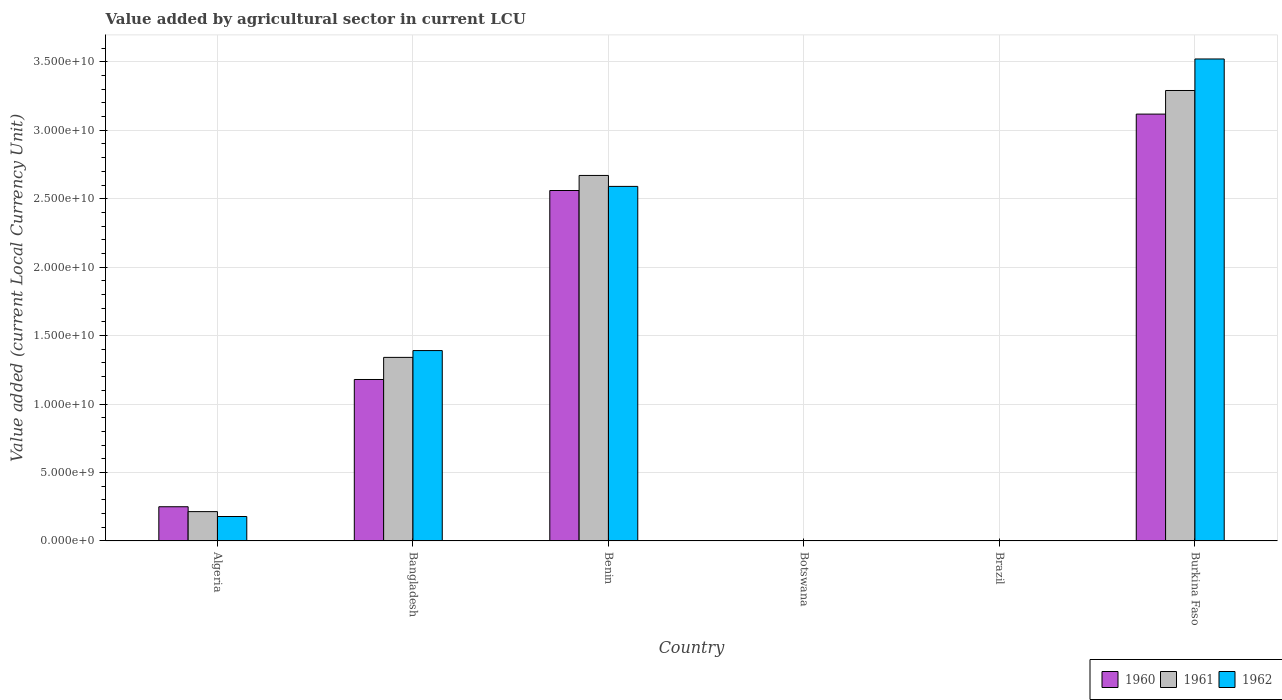Are the number of bars per tick equal to the number of legend labels?
Provide a short and direct response. Yes. How many bars are there on the 5th tick from the right?
Your answer should be very brief. 3. What is the label of the 6th group of bars from the left?
Make the answer very short. Burkina Faso. In how many cases, is the number of bars for a given country not equal to the number of legend labels?
Your response must be concise. 0. What is the value added by agricultural sector in 1960 in Brazil?
Your answer should be compact. 0. Across all countries, what is the maximum value added by agricultural sector in 1962?
Offer a terse response. 3.52e+1. Across all countries, what is the minimum value added by agricultural sector in 1960?
Ensure brevity in your answer.  0. In which country was the value added by agricultural sector in 1962 maximum?
Provide a succinct answer. Burkina Faso. What is the total value added by agricultural sector in 1960 in the graph?
Your answer should be very brief. 7.11e+1. What is the difference between the value added by agricultural sector in 1961 in Brazil and that in Burkina Faso?
Your answer should be very brief. -3.29e+1. What is the difference between the value added by agricultural sector in 1960 in Bangladesh and the value added by agricultural sector in 1961 in Burkina Faso?
Keep it short and to the point. -2.11e+1. What is the average value added by agricultural sector in 1962 per country?
Provide a succinct answer. 1.28e+1. What is the difference between the value added by agricultural sector of/in 1962 and value added by agricultural sector of/in 1961 in Burkina Faso?
Give a very brief answer. 2.30e+09. In how many countries, is the value added by agricultural sector in 1961 greater than 14000000000 LCU?
Provide a short and direct response. 2. What is the ratio of the value added by agricultural sector in 1962 in Bangladesh to that in Benin?
Give a very brief answer. 0.54. Is the difference between the value added by agricultural sector in 1962 in Brazil and Burkina Faso greater than the difference between the value added by agricultural sector in 1961 in Brazil and Burkina Faso?
Provide a short and direct response. No. What is the difference between the highest and the second highest value added by agricultural sector in 1962?
Give a very brief answer. 9.31e+09. What is the difference between the highest and the lowest value added by agricultural sector in 1960?
Ensure brevity in your answer.  3.12e+1. Are all the bars in the graph horizontal?
Ensure brevity in your answer.  No. What is the difference between two consecutive major ticks on the Y-axis?
Provide a succinct answer. 5.00e+09. Are the values on the major ticks of Y-axis written in scientific E-notation?
Your answer should be compact. Yes. Does the graph contain grids?
Ensure brevity in your answer.  Yes. Where does the legend appear in the graph?
Provide a short and direct response. Bottom right. How many legend labels are there?
Give a very brief answer. 3. How are the legend labels stacked?
Provide a short and direct response. Horizontal. What is the title of the graph?
Your answer should be very brief. Value added by agricultural sector in current LCU. What is the label or title of the X-axis?
Ensure brevity in your answer.  Country. What is the label or title of the Y-axis?
Provide a short and direct response. Value added (current Local Currency Unit). What is the Value added (current Local Currency Unit) of 1960 in Algeria?
Your answer should be compact. 2.50e+09. What is the Value added (current Local Currency Unit) in 1961 in Algeria?
Your answer should be compact. 2.14e+09. What is the Value added (current Local Currency Unit) of 1962 in Algeria?
Provide a succinct answer. 1.78e+09. What is the Value added (current Local Currency Unit) of 1960 in Bangladesh?
Ensure brevity in your answer.  1.18e+1. What is the Value added (current Local Currency Unit) of 1961 in Bangladesh?
Your response must be concise. 1.34e+1. What is the Value added (current Local Currency Unit) of 1962 in Bangladesh?
Provide a short and direct response. 1.39e+1. What is the Value added (current Local Currency Unit) of 1960 in Benin?
Your response must be concise. 2.56e+1. What is the Value added (current Local Currency Unit) in 1961 in Benin?
Your answer should be compact. 2.67e+1. What is the Value added (current Local Currency Unit) in 1962 in Benin?
Provide a succinct answer. 2.59e+1. What is the Value added (current Local Currency Unit) in 1960 in Botswana?
Offer a terse response. 9.38e+06. What is the Value added (current Local Currency Unit) in 1961 in Botswana?
Provide a succinct answer. 9.86e+06. What is the Value added (current Local Currency Unit) in 1962 in Botswana?
Your answer should be compact. 1.03e+07. What is the Value added (current Local Currency Unit) in 1960 in Brazil?
Keep it short and to the point. 0. What is the Value added (current Local Currency Unit) in 1961 in Brazil?
Make the answer very short. 0. What is the Value added (current Local Currency Unit) of 1962 in Brazil?
Ensure brevity in your answer.  0. What is the Value added (current Local Currency Unit) of 1960 in Burkina Faso?
Keep it short and to the point. 3.12e+1. What is the Value added (current Local Currency Unit) of 1961 in Burkina Faso?
Your response must be concise. 3.29e+1. What is the Value added (current Local Currency Unit) of 1962 in Burkina Faso?
Provide a succinct answer. 3.52e+1. Across all countries, what is the maximum Value added (current Local Currency Unit) in 1960?
Ensure brevity in your answer.  3.12e+1. Across all countries, what is the maximum Value added (current Local Currency Unit) of 1961?
Offer a terse response. 3.29e+1. Across all countries, what is the maximum Value added (current Local Currency Unit) in 1962?
Ensure brevity in your answer.  3.52e+1. Across all countries, what is the minimum Value added (current Local Currency Unit) of 1960?
Your answer should be compact. 0. Across all countries, what is the minimum Value added (current Local Currency Unit) of 1961?
Make the answer very short. 0. Across all countries, what is the minimum Value added (current Local Currency Unit) in 1962?
Make the answer very short. 0. What is the total Value added (current Local Currency Unit) in 1960 in the graph?
Your answer should be very brief. 7.11e+1. What is the total Value added (current Local Currency Unit) of 1961 in the graph?
Your answer should be very brief. 7.52e+1. What is the total Value added (current Local Currency Unit) of 1962 in the graph?
Your answer should be compact. 7.68e+1. What is the difference between the Value added (current Local Currency Unit) in 1960 in Algeria and that in Bangladesh?
Keep it short and to the point. -9.29e+09. What is the difference between the Value added (current Local Currency Unit) in 1961 in Algeria and that in Bangladesh?
Ensure brevity in your answer.  -1.13e+1. What is the difference between the Value added (current Local Currency Unit) of 1962 in Algeria and that in Bangladesh?
Provide a short and direct response. -1.21e+1. What is the difference between the Value added (current Local Currency Unit) of 1960 in Algeria and that in Benin?
Give a very brief answer. -2.31e+1. What is the difference between the Value added (current Local Currency Unit) of 1961 in Algeria and that in Benin?
Make the answer very short. -2.46e+1. What is the difference between the Value added (current Local Currency Unit) of 1962 in Algeria and that in Benin?
Make the answer very short. -2.41e+1. What is the difference between the Value added (current Local Currency Unit) of 1960 in Algeria and that in Botswana?
Give a very brief answer. 2.49e+09. What is the difference between the Value added (current Local Currency Unit) of 1961 in Algeria and that in Botswana?
Your response must be concise. 2.13e+09. What is the difference between the Value added (current Local Currency Unit) of 1962 in Algeria and that in Botswana?
Offer a very short reply. 1.77e+09. What is the difference between the Value added (current Local Currency Unit) in 1960 in Algeria and that in Brazil?
Offer a terse response. 2.50e+09. What is the difference between the Value added (current Local Currency Unit) of 1961 in Algeria and that in Brazil?
Your response must be concise. 2.14e+09. What is the difference between the Value added (current Local Currency Unit) of 1962 in Algeria and that in Brazil?
Ensure brevity in your answer.  1.78e+09. What is the difference between the Value added (current Local Currency Unit) of 1960 in Algeria and that in Burkina Faso?
Provide a short and direct response. -2.87e+1. What is the difference between the Value added (current Local Currency Unit) in 1961 in Algeria and that in Burkina Faso?
Ensure brevity in your answer.  -3.08e+1. What is the difference between the Value added (current Local Currency Unit) in 1962 in Algeria and that in Burkina Faso?
Provide a succinct answer. -3.34e+1. What is the difference between the Value added (current Local Currency Unit) in 1960 in Bangladesh and that in Benin?
Your answer should be compact. -1.38e+1. What is the difference between the Value added (current Local Currency Unit) of 1961 in Bangladesh and that in Benin?
Offer a terse response. -1.33e+1. What is the difference between the Value added (current Local Currency Unit) in 1962 in Bangladesh and that in Benin?
Make the answer very short. -1.20e+1. What is the difference between the Value added (current Local Currency Unit) of 1960 in Bangladesh and that in Botswana?
Offer a very short reply. 1.18e+1. What is the difference between the Value added (current Local Currency Unit) of 1961 in Bangladesh and that in Botswana?
Offer a terse response. 1.34e+1. What is the difference between the Value added (current Local Currency Unit) of 1962 in Bangladesh and that in Botswana?
Give a very brief answer. 1.39e+1. What is the difference between the Value added (current Local Currency Unit) of 1960 in Bangladesh and that in Brazil?
Ensure brevity in your answer.  1.18e+1. What is the difference between the Value added (current Local Currency Unit) in 1961 in Bangladesh and that in Brazil?
Provide a short and direct response. 1.34e+1. What is the difference between the Value added (current Local Currency Unit) of 1962 in Bangladesh and that in Brazil?
Provide a short and direct response. 1.39e+1. What is the difference between the Value added (current Local Currency Unit) of 1960 in Bangladesh and that in Burkina Faso?
Offer a terse response. -1.94e+1. What is the difference between the Value added (current Local Currency Unit) of 1961 in Bangladesh and that in Burkina Faso?
Give a very brief answer. -1.95e+1. What is the difference between the Value added (current Local Currency Unit) in 1962 in Bangladesh and that in Burkina Faso?
Provide a succinct answer. -2.13e+1. What is the difference between the Value added (current Local Currency Unit) of 1960 in Benin and that in Botswana?
Your answer should be very brief. 2.56e+1. What is the difference between the Value added (current Local Currency Unit) of 1961 in Benin and that in Botswana?
Your answer should be compact. 2.67e+1. What is the difference between the Value added (current Local Currency Unit) in 1962 in Benin and that in Botswana?
Give a very brief answer. 2.59e+1. What is the difference between the Value added (current Local Currency Unit) in 1960 in Benin and that in Brazil?
Your answer should be very brief. 2.56e+1. What is the difference between the Value added (current Local Currency Unit) in 1961 in Benin and that in Brazil?
Your response must be concise. 2.67e+1. What is the difference between the Value added (current Local Currency Unit) in 1962 in Benin and that in Brazil?
Keep it short and to the point. 2.59e+1. What is the difference between the Value added (current Local Currency Unit) of 1960 in Benin and that in Burkina Faso?
Your answer should be compact. -5.58e+09. What is the difference between the Value added (current Local Currency Unit) in 1961 in Benin and that in Burkina Faso?
Keep it short and to the point. -6.21e+09. What is the difference between the Value added (current Local Currency Unit) of 1962 in Benin and that in Burkina Faso?
Offer a terse response. -9.31e+09. What is the difference between the Value added (current Local Currency Unit) in 1960 in Botswana and that in Brazil?
Offer a very short reply. 9.38e+06. What is the difference between the Value added (current Local Currency Unit) in 1961 in Botswana and that in Brazil?
Provide a short and direct response. 9.86e+06. What is the difference between the Value added (current Local Currency Unit) of 1962 in Botswana and that in Brazil?
Ensure brevity in your answer.  1.03e+07. What is the difference between the Value added (current Local Currency Unit) in 1960 in Botswana and that in Burkina Faso?
Provide a succinct answer. -3.12e+1. What is the difference between the Value added (current Local Currency Unit) of 1961 in Botswana and that in Burkina Faso?
Offer a terse response. -3.29e+1. What is the difference between the Value added (current Local Currency Unit) of 1962 in Botswana and that in Burkina Faso?
Your response must be concise. -3.52e+1. What is the difference between the Value added (current Local Currency Unit) of 1960 in Brazil and that in Burkina Faso?
Give a very brief answer. -3.12e+1. What is the difference between the Value added (current Local Currency Unit) in 1961 in Brazil and that in Burkina Faso?
Ensure brevity in your answer.  -3.29e+1. What is the difference between the Value added (current Local Currency Unit) in 1962 in Brazil and that in Burkina Faso?
Make the answer very short. -3.52e+1. What is the difference between the Value added (current Local Currency Unit) in 1960 in Algeria and the Value added (current Local Currency Unit) in 1961 in Bangladesh?
Your answer should be very brief. -1.09e+1. What is the difference between the Value added (current Local Currency Unit) of 1960 in Algeria and the Value added (current Local Currency Unit) of 1962 in Bangladesh?
Your response must be concise. -1.14e+1. What is the difference between the Value added (current Local Currency Unit) in 1961 in Algeria and the Value added (current Local Currency Unit) in 1962 in Bangladesh?
Keep it short and to the point. -1.18e+1. What is the difference between the Value added (current Local Currency Unit) in 1960 in Algeria and the Value added (current Local Currency Unit) in 1961 in Benin?
Keep it short and to the point. -2.42e+1. What is the difference between the Value added (current Local Currency Unit) in 1960 in Algeria and the Value added (current Local Currency Unit) in 1962 in Benin?
Provide a short and direct response. -2.34e+1. What is the difference between the Value added (current Local Currency Unit) in 1961 in Algeria and the Value added (current Local Currency Unit) in 1962 in Benin?
Offer a very short reply. -2.38e+1. What is the difference between the Value added (current Local Currency Unit) in 1960 in Algeria and the Value added (current Local Currency Unit) in 1961 in Botswana?
Provide a succinct answer. 2.49e+09. What is the difference between the Value added (current Local Currency Unit) of 1960 in Algeria and the Value added (current Local Currency Unit) of 1962 in Botswana?
Provide a succinct answer. 2.49e+09. What is the difference between the Value added (current Local Currency Unit) in 1961 in Algeria and the Value added (current Local Currency Unit) in 1962 in Botswana?
Your response must be concise. 2.13e+09. What is the difference between the Value added (current Local Currency Unit) of 1960 in Algeria and the Value added (current Local Currency Unit) of 1961 in Brazil?
Ensure brevity in your answer.  2.50e+09. What is the difference between the Value added (current Local Currency Unit) of 1960 in Algeria and the Value added (current Local Currency Unit) of 1962 in Brazil?
Give a very brief answer. 2.50e+09. What is the difference between the Value added (current Local Currency Unit) of 1961 in Algeria and the Value added (current Local Currency Unit) of 1962 in Brazil?
Make the answer very short. 2.14e+09. What is the difference between the Value added (current Local Currency Unit) of 1960 in Algeria and the Value added (current Local Currency Unit) of 1961 in Burkina Faso?
Your answer should be very brief. -3.04e+1. What is the difference between the Value added (current Local Currency Unit) in 1960 in Algeria and the Value added (current Local Currency Unit) in 1962 in Burkina Faso?
Keep it short and to the point. -3.27e+1. What is the difference between the Value added (current Local Currency Unit) of 1961 in Algeria and the Value added (current Local Currency Unit) of 1962 in Burkina Faso?
Your answer should be very brief. -3.31e+1. What is the difference between the Value added (current Local Currency Unit) in 1960 in Bangladesh and the Value added (current Local Currency Unit) in 1961 in Benin?
Your answer should be compact. -1.49e+1. What is the difference between the Value added (current Local Currency Unit) in 1960 in Bangladesh and the Value added (current Local Currency Unit) in 1962 in Benin?
Your response must be concise. -1.41e+1. What is the difference between the Value added (current Local Currency Unit) in 1961 in Bangladesh and the Value added (current Local Currency Unit) in 1962 in Benin?
Your answer should be very brief. -1.25e+1. What is the difference between the Value added (current Local Currency Unit) in 1960 in Bangladesh and the Value added (current Local Currency Unit) in 1961 in Botswana?
Give a very brief answer. 1.18e+1. What is the difference between the Value added (current Local Currency Unit) of 1960 in Bangladesh and the Value added (current Local Currency Unit) of 1962 in Botswana?
Give a very brief answer. 1.18e+1. What is the difference between the Value added (current Local Currency Unit) in 1961 in Bangladesh and the Value added (current Local Currency Unit) in 1962 in Botswana?
Your answer should be very brief. 1.34e+1. What is the difference between the Value added (current Local Currency Unit) in 1960 in Bangladesh and the Value added (current Local Currency Unit) in 1961 in Brazil?
Your answer should be compact. 1.18e+1. What is the difference between the Value added (current Local Currency Unit) in 1960 in Bangladesh and the Value added (current Local Currency Unit) in 1962 in Brazil?
Offer a terse response. 1.18e+1. What is the difference between the Value added (current Local Currency Unit) in 1961 in Bangladesh and the Value added (current Local Currency Unit) in 1962 in Brazil?
Keep it short and to the point. 1.34e+1. What is the difference between the Value added (current Local Currency Unit) of 1960 in Bangladesh and the Value added (current Local Currency Unit) of 1961 in Burkina Faso?
Ensure brevity in your answer.  -2.11e+1. What is the difference between the Value added (current Local Currency Unit) of 1960 in Bangladesh and the Value added (current Local Currency Unit) of 1962 in Burkina Faso?
Provide a succinct answer. -2.34e+1. What is the difference between the Value added (current Local Currency Unit) in 1961 in Bangladesh and the Value added (current Local Currency Unit) in 1962 in Burkina Faso?
Your response must be concise. -2.18e+1. What is the difference between the Value added (current Local Currency Unit) of 1960 in Benin and the Value added (current Local Currency Unit) of 1961 in Botswana?
Your answer should be compact. 2.56e+1. What is the difference between the Value added (current Local Currency Unit) in 1960 in Benin and the Value added (current Local Currency Unit) in 1962 in Botswana?
Ensure brevity in your answer.  2.56e+1. What is the difference between the Value added (current Local Currency Unit) of 1961 in Benin and the Value added (current Local Currency Unit) of 1962 in Botswana?
Your answer should be compact. 2.67e+1. What is the difference between the Value added (current Local Currency Unit) in 1960 in Benin and the Value added (current Local Currency Unit) in 1961 in Brazil?
Offer a very short reply. 2.56e+1. What is the difference between the Value added (current Local Currency Unit) in 1960 in Benin and the Value added (current Local Currency Unit) in 1962 in Brazil?
Ensure brevity in your answer.  2.56e+1. What is the difference between the Value added (current Local Currency Unit) in 1961 in Benin and the Value added (current Local Currency Unit) in 1962 in Brazil?
Provide a succinct answer. 2.67e+1. What is the difference between the Value added (current Local Currency Unit) of 1960 in Benin and the Value added (current Local Currency Unit) of 1961 in Burkina Faso?
Offer a very short reply. -7.31e+09. What is the difference between the Value added (current Local Currency Unit) of 1960 in Benin and the Value added (current Local Currency Unit) of 1962 in Burkina Faso?
Offer a very short reply. -9.61e+09. What is the difference between the Value added (current Local Currency Unit) of 1961 in Benin and the Value added (current Local Currency Unit) of 1962 in Burkina Faso?
Keep it short and to the point. -8.51e+09. What is the difference between the Value added (current Local Currency Unit) of 1960 in Botswana and the Value added (current Local Currency Unit) of 1961 in Brazil?
Give a very brief answer. 9.38e+06. What is the difference between the Value added (current Local Currency Unit) in 1960 in Botswana and the Value added (current Local Currency Unit) in 1962 in Brazil?
Keep it short and to the point. 9.38e+06. What is the difference between the Value added (current Local Currency Unit) in 1961 in Botswana and the Value added (current Local Currency Unit) in 1962 in Brazil?
Make the answer very short. 9.86e+06. What is the difference between the Value added (current Local Currency Unit) in 1960 in Botswana and the Value added (current Local Currency Unit) in 1961 in Burkina Faso?
Make the answer very short. -3.29e+1. What is the difference between the Value added (current Local Currency Unit) of 1960 in Botswana and the Value added (current Local Currency Unit) of 1962 in Burkina Faso?
Keep it short and to the point. -3.52e+1. What is the difference between the Value added (current Local Currency Unit) in 1961 in Botswana and the Value added (current Local Currency Unit) in 1962 in Burkina Faso?
Provide a succinct answer. -3.52e+1. What is the difference between the Value added (current Local Currency Unit) in 1960 in Brazil and the Value added (current Local Currency Unit) in 1961 in Burkina Faso?
Provide a succinct answer. -3.29e+1. What is the difference between the Value added (current Local Currency Unit) of 1960 in Brazil and the Value added (current Local Currency Unit) of 1962 in Burkina Faso?
Provide a succinct answer. -3.52e+1. What is the difference between the Value added (current Local Currency Unit) of 1961 in Brazil and the Value added (current Local Currency Unit) of 1962 in Burkina Faso?
Ensure brevity in your answer.  -3.52e+1. What is the average Value added (current Local Currency Unit) of 1960 per country?
Offer a very short reply. 1.18e+1. What is the average Value added (current Local Currency Unit) in 1961 per country?
Offer a very short reply. 1.25e+1. What is the average Value added (current Local Currency Unit) in 1962 per country?
Your answer should be compact. 1.28e+1. What is the difference between the Value added (current Local Currency Unit) in 1960 and Value added (current Local Currency Unit) in 1961 in Algeria?
Your response must be concise. 3.57e+08. What is the difference between the Value added (current Local Currency Unit) in 1960 and Value added (current Local Currency Unit) in 1962 in Algeria?
Provide a succinct answer. 7.14e+08. What is the difference between the Value added (current Local Currency Unit) of 1961 and Value added (current Local Currency Unit) of 1962 in Algeria?
Ensure brevity in your answer.  3.57e+08. What is the difference between the Value added (current Local Currency Unit) of 1960 and Value added (current Local Currency Unit) of 1961 in Bangladesh?
Offer a terse response. -1.62e+09. What is the difference between the Value added (current Local Currency Unit) of 1960 and Value added (current Local Currency Unit) of 1962 in Bangladesh?
Ensure brevity in your answer.  -2.11e+09. What is the difference between the Value added (current Local Currency Unit) in 1961 and Value added (current Local Currency Unit) in 1962 in Bangladesh?
Offer a very short reply. -4.98e+08. What is the difference between the Value added (current Local Currency Unit) of 1960 and Value added (current Local Currency Unit) of 1961 in Benin?
Provide a succinct answer. -1.10e+09. What is the difference between the Value added (current Local Currency Unit) in 1960 and Value added (current Local Currency Unit) in 1962 in Benin?
Provide a succinct answer. -3.00e+08. What is the difference between the Value added (current Local Currency Unit) in 1961 and Value added (current Local Currency Unit) in 1962 in Benin?
Your answer should be very brief. 8.00e+08. What is the difference between the Value added (current Local Currency Unit) in 1960 and Value added (current Local Currency Unit) in 1961 in Botswana?
Your answer should be compact. -4.83e+05. What is the difference between the Value added (current Local Currency Unit) in 1960 and Value added (current Local Currency Unit) in 1962 in Botswana?
Your answer should be compact. -9.65e+05. What is the difference between the Value added (current Local Currency Unit) in 1961 and Value added (current Local Currency Unit) in 1962 in Botswana?
Your answer should be very brief. -4.83e+05. What is the difference between the Value added (current Local Currency Unit) in 1960 and Value added (current Local Currency Unit) in 1961 in Brazil?
Your answer should be very brief. -0. What is the difference between the Value added (current Local Currency Unit) of 1960 and Value added (current Local Currency Unit) of 1962 in Brazil?
Ensure brevity in your answer.  -0. What is the difference between the Value added (current Local Currency Unit) in 1961 and Value added (current Local Currency Unit) in 1962 in Brazil?
Give a very brief answer. -0. What is the difference between the Value added (current Local Currency Unit) of 1960 and Value added (current Local Currency Unit) of 1961 in Burkina Faso?
Offer a terse response. -1.73e+09. What is the difference between the Value added (current Local Currency Unit) in 1960 and Value added (current Local Currency Unit) in 1962 in Burkina Faso?
Provide a short and direct response. -4.03e+09. What is the difference between the Value added (current Local Currency Unit) of 1961 and Value added (current Local Currency Unit) of 1962 in Burkina Faso?
Your response must be concise. -2.30e+09. What is the ratio of the Value added (current Local Currency Unit) of 1960 in Algeria to that in Bangladesh?
Provide a succinct answer. 0.21. What is the ratio of the Value added (current Local Currency Unit) of 1961 in Algeria to that in Bangladesh?
Provide a succinct answer. 0.16. What is the ratio of the Value added (current Local Currency Unit) in 1962 in Algeria to that in Bangladesh?
Give a very brief answer. 0.13. What is the ratio of the Value added (current Local Currency Unit) of 1960 in Algeria to that in Benin?
Provide a short and direct response. 0.1. What is the ratio of the Value added (current Local Currency Unit) of 1961 in Algeria to that in Benin?
Provide a succinct answer. 0.08. What is the ratio of the Value added (current Local Currency Unit) in 1962 in Algeria to that in Benin?
Your response must be concise. 0.07. What is the ratio of the Value added (current Local Currency Unit) of 1960 in Algeria to that in Botswana?
Provide a succinct answer. 266.47. What is the ratio of the Value added (current Local Currency Unit) of 1961 in Algeria to that in Botswana?
Ensure brevity in your answer.  217.22. What is the ratio of the Value added (current Local Currency Unit) in 1962 in Algeria to that in Botswana?
Your answer should be very brief. 172.57. What is the ratio of the Value added (current Local Currency Unit) in 1960 in Algeria to that in Brazil?
Offer a very short reply. 1.37e+13. What is the ratio of the Value added (current Local Currency Unit) of 1961 in Algeria to that in Brazil?
Provide a succinct answer. 8.40e+12. What is the ratio of the Value added (current Local Currency Unit) of 1962 in Algeria to that in Brazil?
Your answer should be compact. 4.09e+12. What is the ratio of the Value added (current Local Currency Unit) of 1960 in Algeria to that in Burkina Faso?
Your answer should be compact. 0.08. What is the ratio of the Value added (current Local Currency Unit) of 1961 in Algeria to that in Burkina Faso?
Keep it short and to the point. 0.07. What is the ratio of the Value added (current Local Currency Unit) in 1962 in Algeria to that in Burkina Faso?
Offer a terse response. 0.05. What is the ratio of the Value added (current Local Currency Unit) in 1960 in Bangladesh to that in Benin?
Provide a succinct answer. 0.46. What is the ratio of the Value added (current Local Currency Unit) in 1961 in Bangladesh to that in Benin?
Ensure brevity in your answer.  0.5. What is the ratio of the Value added (current Local Currency Unit) in 1962 in Bangladesh to that in Benin?
Your answer should be compact. 0.54. What is the ratio of the Value added (current Local Currency Unit) of 1960 in Bangladesh to that in Botswana?
Your answer should be very brief. 1257.78. What is the ratio of the Value added (current Local Currency Unit) in 1961 in Bangladesh to that in Botswana?
Your answer should be compact. 1360.12. What is the ratio of the Value added (current Local Currency Unit) in 1962 in Bangladesh to that in Botswana?
Ensure brevity in your answer.  1344.79. What is the ratio of the Value added (current Local Currency Unit) of 1960 in Bangladesh to that in Brazil?
Offer a terse response. 6.48e+13. What is the ratio of the Value added (current Local Currency Unit) in 1961 in Bangladesh to that in Brazil?
Your response must be concise. 5.26e+13. What is the ratio of the Value added (current Local Currency Unit) in 1962 in Bangladesh to that in Brazil?
Ensure brevity in your answer.  3.19e+13. What is the ratio of the Value added (current Local Currency Unit) of 1960 in Bangladesh to that in Burkina Faso?
Your response must be concise. 0.38. What is the ratio of the Value added (current Local Currency Unit) of 1961 in Bangladesh to that in Burkina Faso?
Offer a terse response. 0.41. What is the ratio of the Value added (current Local Currency Unit) in 1962 in Bangladesh to that in Burkina Faso?
Provide a succinct answer. 0.4. What is the ratio of the Value added (current Local Currency Unit) in 1960 in Benin to that in Botswana?
Keep it short and to the point. 2730.26. What is the ratio of the Value added (current Local Currency Unit) in 1961 in Benin to that in Botswana?
Make the answer very short. 2708.19. What is the ratio of the Value added (current Local Currency Unit) in 1962 in Benin to that in Botswana?
Your response must be concise. 2504.45. What is the ratio of the Value added (current Local Currency Unit) in 1960 in Benin to that in Brazil?
Your answer should be compact. 1.41e+14. What is the ratio of the Value added (current Local Currency Unit) of 1961 in Benin to that in Brazil?
Keep it short and to the point. 1.05e+14. What is the ratio of the Value added (current Local Currency Unit) of 1962 in Benin to that in Brazil?
Keep it short and to the point. 5.94e+13. What is the ratio of the Value added (current Local Currency Unit) in 1960 in Benin to that in Burkina Faso?
Your response must be concise. 0.82. What is the ratio of the Value added (current Local Currency Unit) of 1961 in Benin to that in Burkina Faso?
Your answer should be very brief. 0.81. What is the ratio of the Value added (current Local Currency Unit) of 1962 in Benin to that in Burkina Faso?
Your answer should be compact. 0.74. What is the ratio of the Value added (current Local Currency Unit) in 1960 in Botswana to that in Brazil?
Give a very brief answer. 5.15e+1. What is the ratio of the Value added (current Local Currency Unit) of 1961 in Botswana to that in Brazil?
Your answer should be very brief. 3.86e+1. What is the ratio of the Value added (current Local Currency Unit) of 1962 in Botswana to that in Brazil?
Provide a succinct answer. 2.37e+1. What is the ratio of the Value added (current Local Currency Unit) of 1960 in Botswana to that in Burkina Faso?
Offer a terse response. 0. What is the ratio of the Value added (current Local Currency Unit) in 1960 in Brazil to that in Burkina Faso?
Your answer should be very brief. 0. What is the difference between the highest and the second highest Value added (current Local Currency Unit) in 1960?
Your response must be concise. 5.58e+09. What is the difference between the highest and the second highest Value added (current Local Currency Unit) of 1961?
Give a very brief answer. 6.21e+09. What is the difference between the highest and the second highest Value added (current Local Currency Unit) in 1962?
Make the answer very short. 9.31e+09. What is the difference between the highest and the lowest Value added (current Local Currency Unit) in 1960?
Provide a succinct answer. 3.12e+1. What is the difference between the highest and the lowest Value added (current Local Currency Unit) in 1961?
Your response must be concise. 3.29e+1. What is the difference between the highest and the lowest Value added (current Local Currency Unit) in 1962?
Your answer should be very brief. 3.52e+1. 